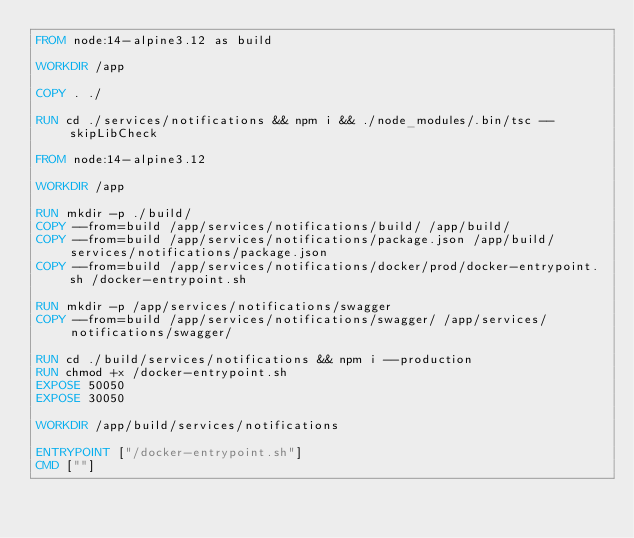<code> <loc_0><loc_0><loc_500><loc_500><_Dockerfile_>FROM node:14-alpine3.12 as build

WORKDIR /app

COPY . ./

RUN cd ./services/notifications && npm i && ./node_modules/.bin/tsc --skipLibCheck

FROM node:14-alpine3.12

WORKDIR /app

RUN mkdir -p ./build/
COPY --from=build /app/services/notifications/build/ /app/build/
COPY --from=build /app/services/notifications/package.json /app/build/services/notifications/package.json
COPY --from=build /app/services/notifications/docker/prod/docker-entrypoint.sh /docker-entrypoint.sh

RUN mkdir -p /app/services/notifications/swagger
COPY --from=build /app/services/notifications/swagger/ /app/services/notifications/swagger/

RUN cd ./build/services/notifications && npm i --production
RUN chmod +x /docker-entrypoint.sh
EXPOSE 50050
EXPOSE 30050

WORKDIR /app/build/services/notifications

ENTRYPOINT ["/docker-entrypoint.sh"]
CMD [""]
</code> 